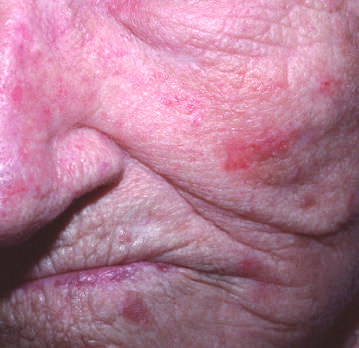where are lesions owing to excessive scale present?
Answer the question using a single word or phrase. On the cheek and nose 